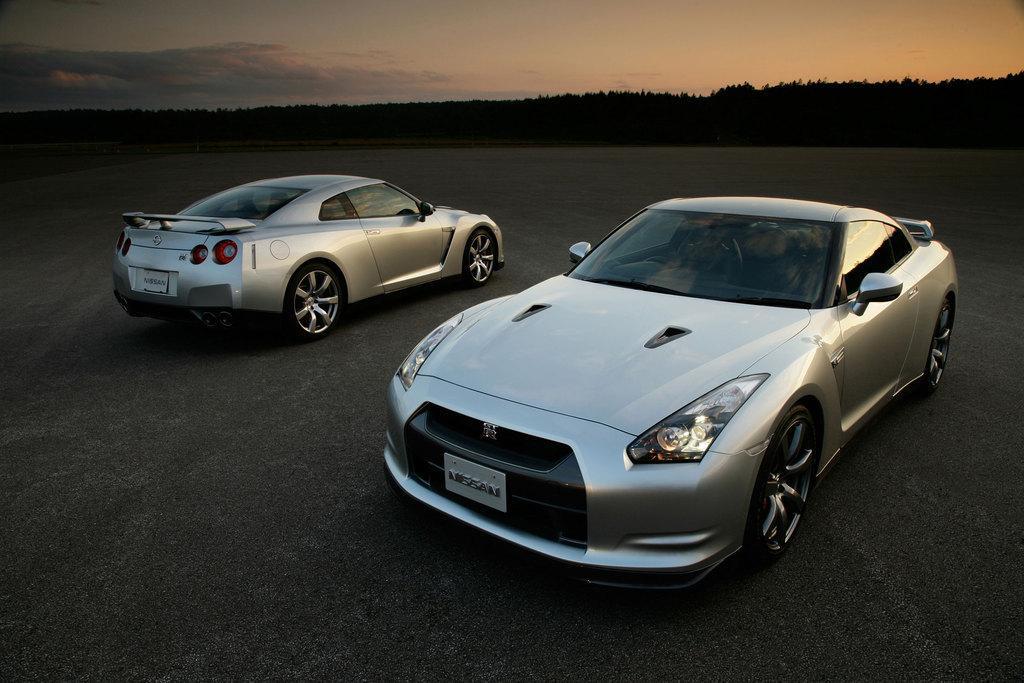Describe this image in one or two sentences. In this image we can see two cars placed on the ground. In the background we can see group of trees and cloudy sky. 